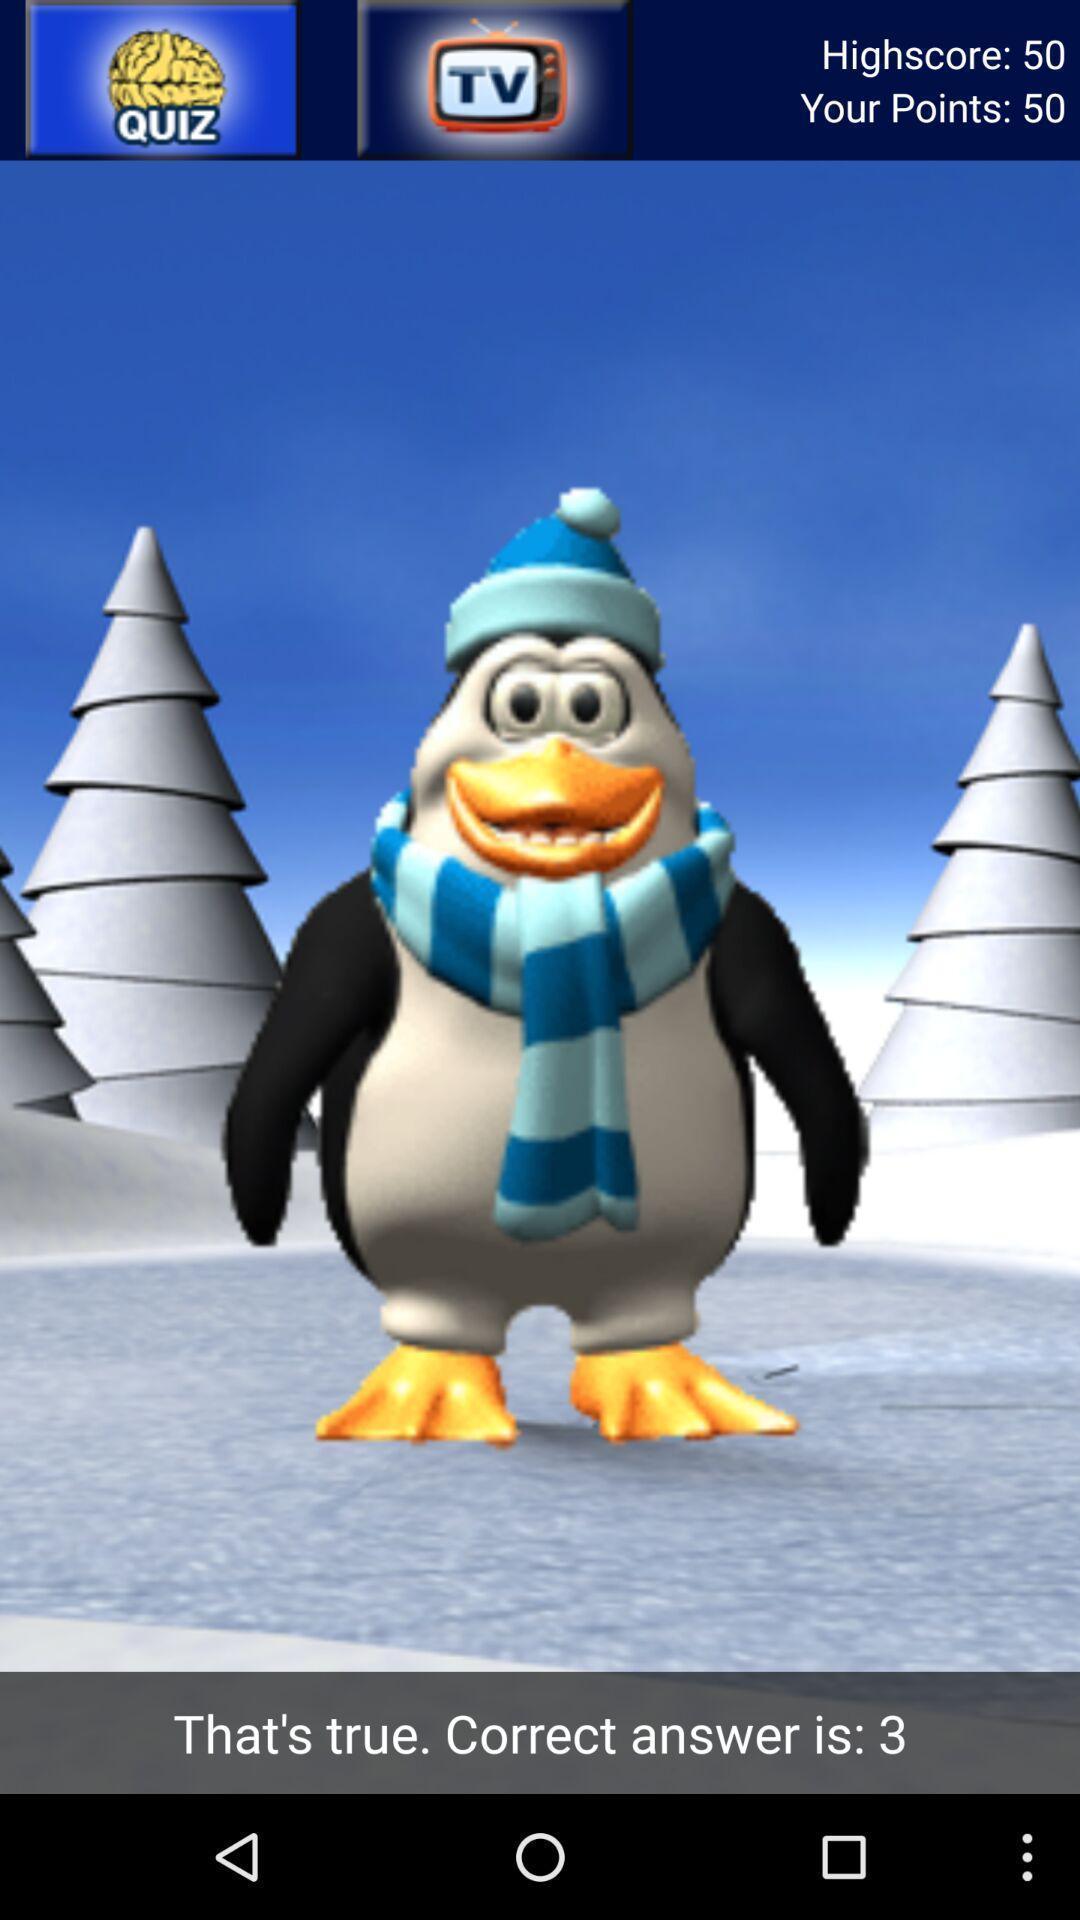Provide a detailed account of this screenshot. Screen showing score page. 